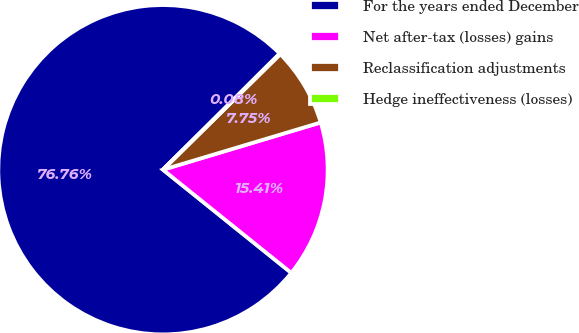Convert chart. <chart><loc_0><loc_0><loc_500><loc_500><pie_chart><fcel>For the years ended December<fcel>Net after-tax (losses) gains<fcel>Reclassification adjustments<fcel>Hedge ineffectiveness (losses)<nl><fcel>76.76%<fcel>15.41%<fcel>7.75%<fcel>0.08%<nl></chart> 